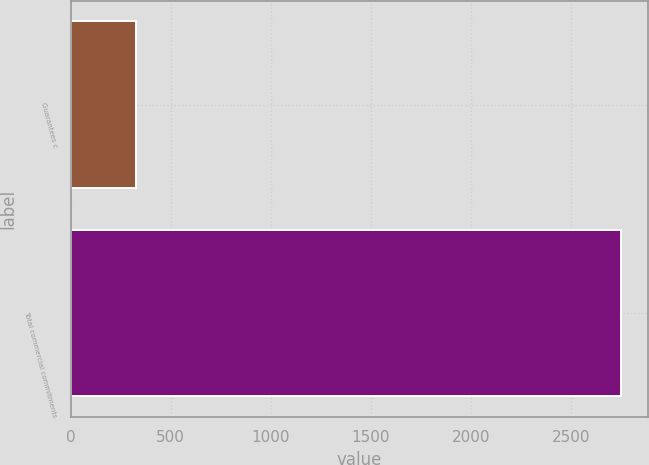Convert chart to OTSL. <chart><loc_0><loc_0><loc_500><loc_500><bar_chart><fcel>Guarantees c<fcel>Total commercial commitments<nl><fcel>325<fcel>2749<nl></chart> 